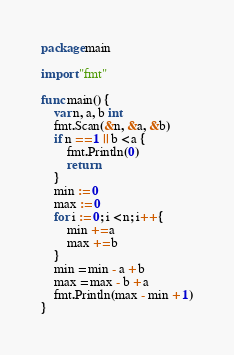<code> <loc_0><loc_0><loc_500><loc_500><_Go_>package main

import "fmt"

func main() {
	var n, a, b int
	fmt.Scan(&n, &a, &b)
	if n == 1 || b < a {
		fmt.Println(0)
		return
	}
	min := 0
	max := 0
	for i := 0; i < n; i++ {
		min += a
		max += b
	}
	min = min - a + b
	max = max - b + a
	fmt.Println(max - min + 1)
}
</code> 